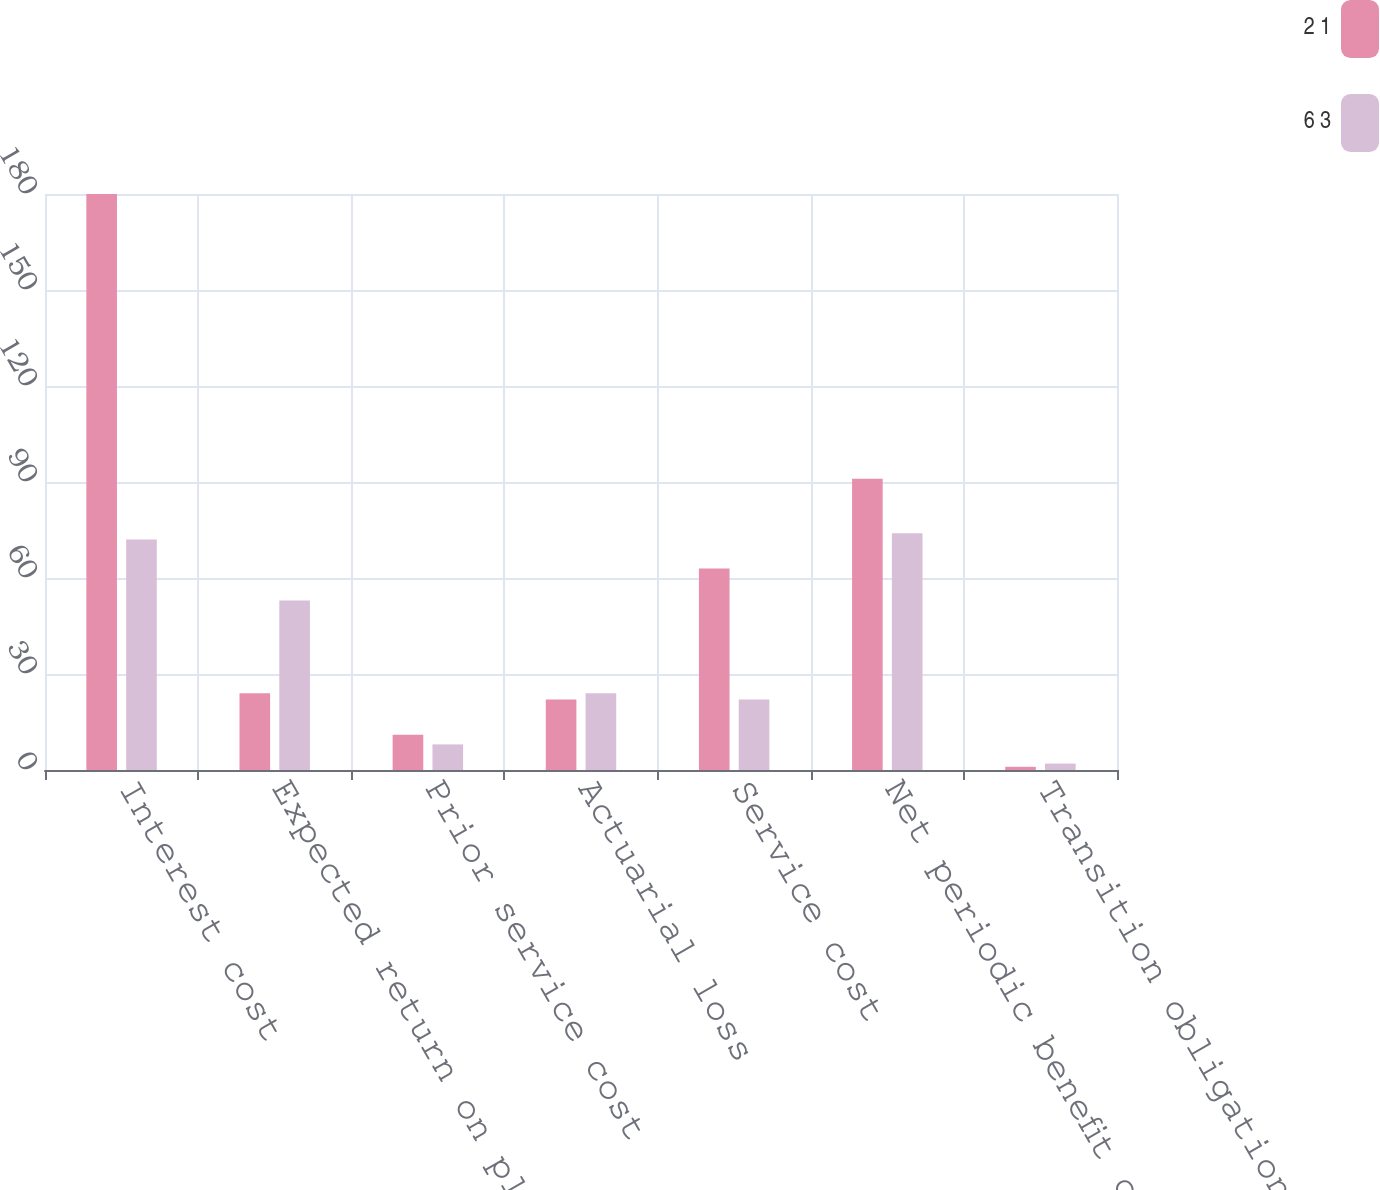<chart> <loc_0><loc_0><loc_500><loc_500><stacked_bar_chart><ecel><fcel>Interest cost<fcel>Expected return on plan assets<fcel>Prior service cost<fcel>Actuarial loss<fcel>Service cost<fcel>Net periodic benefit cost<fcel>Transition obligation (asset)<nl><fcel>2 1<fcel>180<fcel>24<fcel>11<fcel>22<fcel>63<fcel>91<fcel>1<nl><fcel>6 3<fcel>72<fcel>53<fcel>8<fcel>24<fcel>22<fcel>74<fcel>2<nl></chart> 